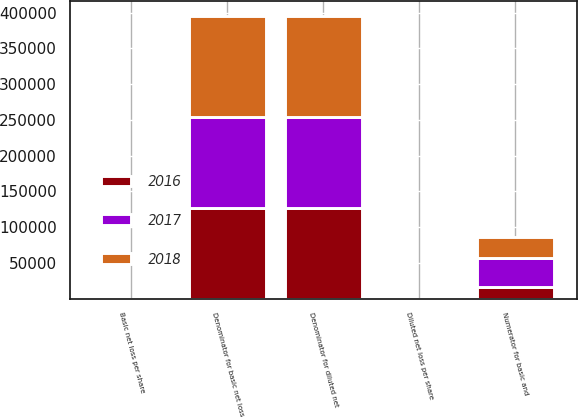Convert chart. <chart><loc_0><loc_0><loc_500><loc_500><stacked_bar_chart><ecel><fcel>Numerator for basic and<fcel>Denominator for basic net loss<fcel>Denominator for diluted net<fcel>Basic net loss per share<fcel>Diluted net loss per share<nl><fcel>2017<fcel>40288<fcel>126946<fcel>126946<fcel>0.32<fcel>0.32<nl><fcel>2016<fcel>16558<fcel>127121<fcel>127121<fcel>0.13<fcel>0.13<nl><fcel>2018<fcel>28845<fcel>141937<fcel>141937<fcel>0.2<fcel>0.2<nl></chart> 